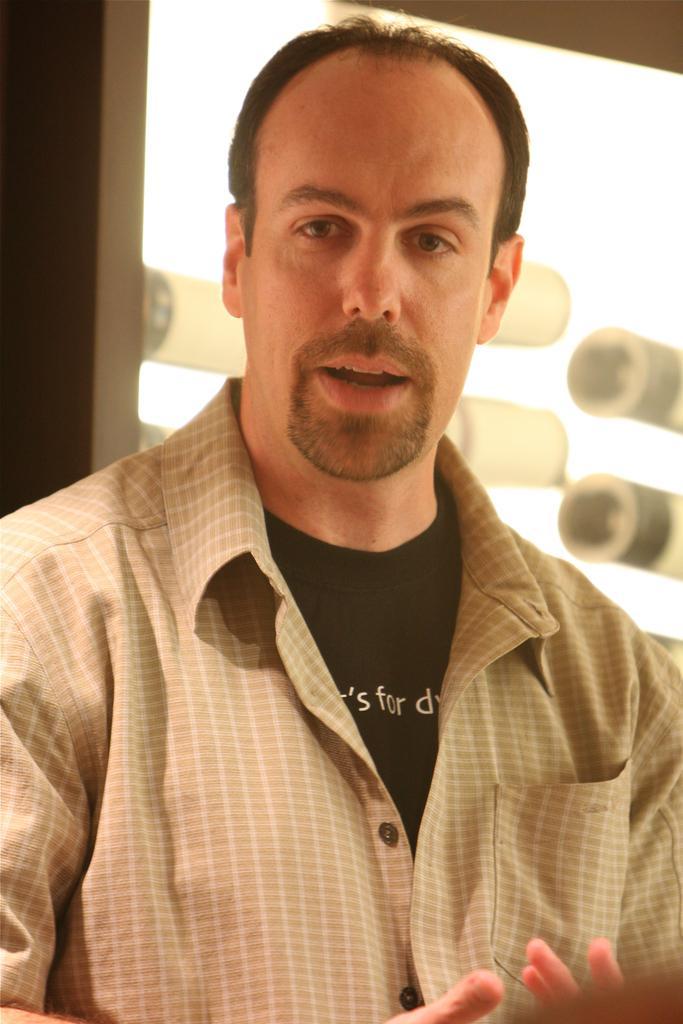Could you give a brief overview of what you see in this image? A man is present wearing a checked shirt and a black shirt. There is light behind him. 